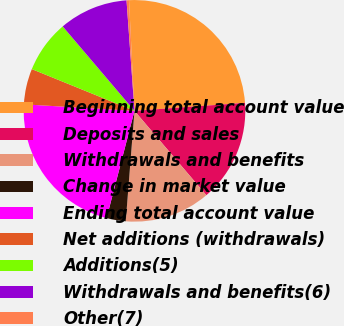Convert chart to OTSL. <chart><loc_0><loc_0><loc_500><loc_500><pie_chart><fcel>Beginning total account value<fcel>Deposits and sales<fcel>Withdrawals and benefits<fcel>Change in market value<fcel>Ending total account value<fcel>Net additions (withdrawals)<fcel>Additions(5)<fcel>Withdrawals and benefits(6)<fcel>Other(7)<nl><fcel>24.63%<fcel>14.92%<fcel>12.49%<fcel>2.79%<fcel>21.89%<fcel>5.21%<fcel>7.64%<fcel>10.07%<fcel>0.36%<nl></chart> 